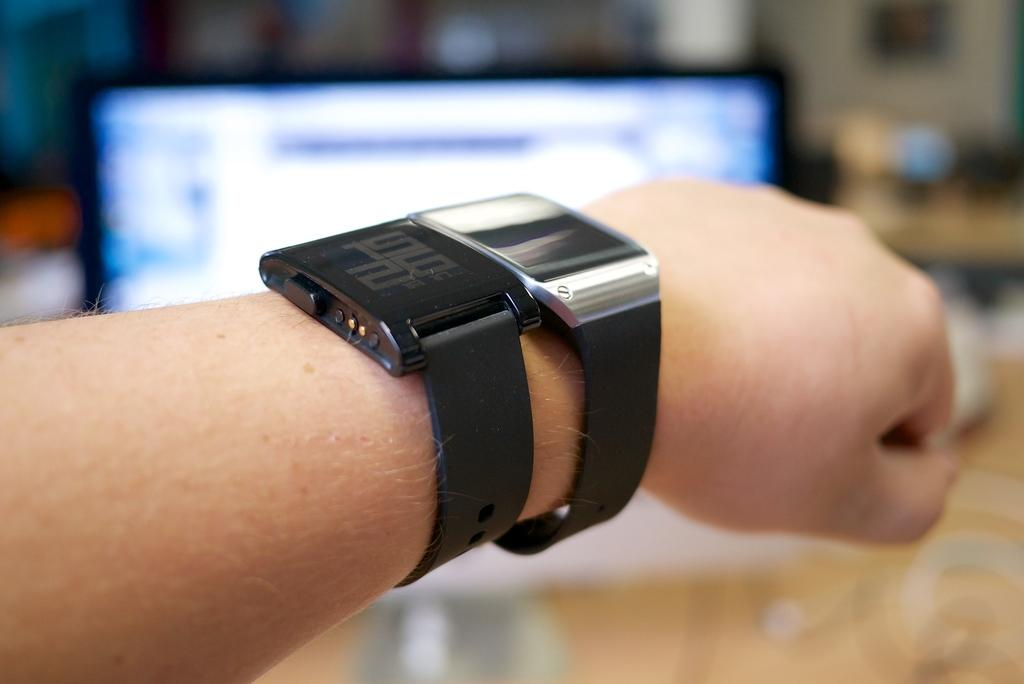What is the main subject of the image? The main subject of the image is a hand. What is unique about the hand in the image? The hand contains watches. Can you describe the background of the image? The background of the image is blurred. How does the hand show respect to the crow in the image? There is no crow present in the image, and the hand is not interacting with any animals or objects that would require showing respect. 